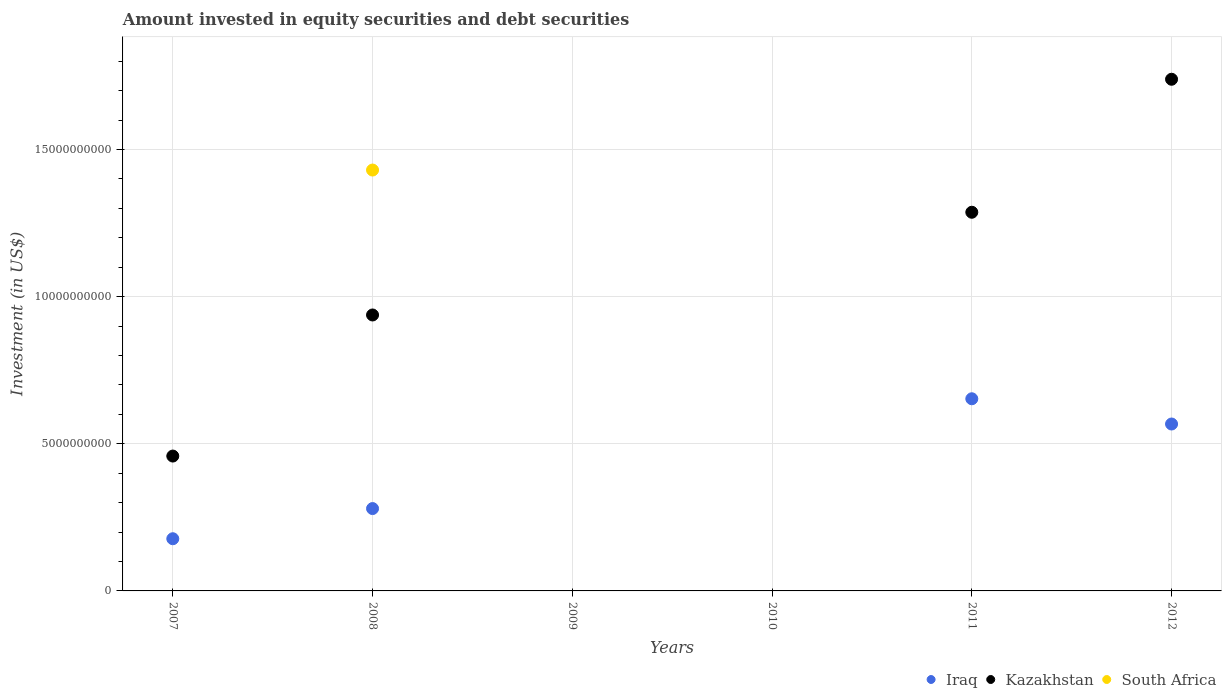Is the number of dotlines equal to the number of legend labels?
Offer a terse response. No. What is the amount invested in equity securities and debt securities in Kazakhstan in 2010?
Give a very brief answer. 0. Across all years, what is the maximum amount invested in equity securities and debt securities in Iraq?
Keep it short and to the point. 6.53e+09. What is the total amount invested in equity securities and debt securities in South Africa in the graph?
Your response must be concise. 1.43e+1. What is the difference between the amount invested in equity securities and debt securities in Kazakhstan in 2012 and the amount invested in equity securities and debt securities in Iraq in 2010?
Offer a very short reply. 1.74e+1. What is the average amount invested in equity securities and debt securities in South Africa per year?
Your answer should be very brief. 2.38e+09. In the year 2008, what is the difference between the amount invested in equity securities and debt securities in South Africa and amount invested in equity securities and debt securities in Kazakhstan?
Give a very brief answer. 4.93e+09. In how many years, is the amount invested in equity securities and debt securities in Iraq greater than 14000000000 US$?
Offer a very short reply. 0. What is the ratio of the amount invested in equity securities and debt securities in Kazakhstan in 2007 to that in 2008?
Provide a succinct answer. 0.49. Is the amount invested in equity securities and debt securities in Kazakhstan in 2008 less than that in 2012?
Make the answer very short. Yes. What is the difference between the highest and the second highest amount invested in equity securities and debt securities in Iraq?
Keep it short and to the point. 8.58e+08. What is the difference between the highest and the lowest amount invested in equity securities and debt securities in South Africa?
Offer a very short reply. 1.43e+1. In how many years, is the amount invested in equity securities and debt securities in Iraq greater than the average amount invested in equity securities and debt securities in Iraq taken over all years?
Offer a terse response. 3. Is the sum of the amount invested in equity securities and debt securities in Kazakhstan in 2007 and 2012 greater than the maximum amount invested in equity securities and debt securities in Iraq across all years?
Offer a very short reply. Yes. Is it the case that in every year, the sum of the amount invested in equity securities and debt securities in South Africa and amount invested in equity securities and debt securities in Iraq  is greater than the amount invested in equity securities and debt securities in Kazakhstan?
Your answer should be very brief. No. Does the amount invested in equity securities and debt securities in Kazakhstan monotonically increase over the years?
Your answer should be very brief. No. Is the amount invested in equity securities and debt securities in Iraq strictly less than the amount invested in equity securities and debt securities in Kazakhstan over the years?
Give a very brief answer. No. How many years are there in the graph?
Provide a succinct answer. 6. What is the difference between two consecutive major ticks on the Y-axis?
Make the answer very short. 5.00e+09. Are the values on the major ticks of Y-axis written in scientific E-notation?
Offer a very short reply. No. Does the graph contain any zero values?
Ensure brevity in your answer.  Yes. Where does the legend appear in the graph?
Your response must be concise. Bottom right. How many legend labels are there?
Ensure brevity in your answer.  3. How are the legend labels stacked?
Give a very brief answer. Horizontal. What is the title of the graph?
Offer a terse response. Amount invested in equity securities and debt securities. What is the label or title of the X-axis?
Make the answer very short. Years. What is the label or title of the Y-axis?
Keep it short and to the point. Investment (in US$). What is the Investment (in US$) in Iraq in 2007?
Your answer should be very brief. 1.77e+09. What is the Investment (in US$) in Kazakhstan in 2007?
Make the answer very short. 4.58e+09. What is the Investment (in US$) in Iraq in 2008?
Provide a succinct answer. 2.80e+09. What is the Investment (in US$) of Kazakhstan in 2008?
Make the answer very short. 9.38e+09. What is the Investment (in US$) of South Africa in 2008?
Make the answer very short. 1.43e+1. What is the Investment (in US$) of Kazakhstan in 2009?
Give a very brief answer. 0. What is the Investment (in US$) in South Africa in 2010?
Your answer should be compact. 0. What is the Investment (in US$) of Iraq in 2011?
Keep it short and to the point. 6.53e+09. What is the Investment (in US$) in Kazakhstan in 2011?
Ensure brevity in your answer.  1.29e+1. What is the Investment (in US$) of Iraq in 2012?
Offer a very short reply. 5.67e+09. What is the Investment (in US$) in Kazakhstan in 2012?
Offer a terse response. 1.74e+1. What is the Investment (in US$) in South Africa in 2012?
Give a very brief answer. 0. Across all years, what is the maximum Investment (in US$) of Iraq?
Give a very brief answer. 6.53e+09. Across all years, what is the maximum Investment (in US$) of Kazakhstan?
Give a very brief answer. 1.74e+1. Across all years, what is the maximum Investment (in US$) in South Africa?
Make the answer very short. 1.43e+1. Across all years, what is the minimum Investment (in US$) of Kazakhstan?
Offer a very short reply. 0. Across all years, what is the minimum Investment (in US$) in South Africa?
Offer a very short reply. 0. What is the total Investment (in US$) in Iraq in the graph?
Offer a terse response. 1.68e+1. What is the total Investment (in US$) of Kazakhstan in the graph?
Keep it short and to the point. 4.42e+1. What is the total Investment (in US$) in South Africa in the graph?
Offer a terse response. 1.43e+1. What is the difference between the Investment (in US$) in Iraq in 2007 and that in 2008?
Offer a very short reply. -1.03e+09. What is the difference between the Investment (in US$) in Kazakhstan in 2007 and that in 2008?
Your answer should be compact. -4.79e+09. What is the difference between the Investment (in US$) in Iraq in 2007 and that in 2011?
Ensure brevity in your answer.  -4.76e+09. What is the difference between the Investment (in US$) of Kazakhstan in 2007 and that in 2011?
Keep it short and to the point. -8.29e+09. What is the difference between the Investment (in US$) of Iraq in 2007 and that in 2012?
Your answer should be compact. -3.90e+09. What is the difference between the Investment (in US$) in Kazakhstan in 2007 and that in 2012?
Ensure brevity in your answer.  -1.28e+1. What is the difference between the Investment (in US$) in Iraq in 2008 and that in 2011?
Your answer should be compact. -3.73e+09. What is the difference between the Investment (in US$) in Kazakhstan in 2008 and that in 2011?
Give a very brief answer. -3.49e+09. What is the difference between the Investment (in US$) in Iraq in 2008 and that in 2012?
Provide a succinct answer. -2.87e+09. What is the difference between the Investment (in US$) of Kazakhstan in 2008 and that in 2012?
Offer a terse response. -8.01e+09. What is the difference between the Investment (in US$) of Iraq in 2011 and that in 2012?
Your response must be concise. 8.58e+08. What is the difference between the Investment (in US$) in Kazakhstan in 2011 and that in 2012?
Offer a terse response. -4.52e+09. What is the difference between the Investment (in US$) of Iraq in 2007 and the Investment (in US$) of Kazakhstan in 2008?
Keep it short and to the point. -7.60e+09. What is the difference between the Investment (in US$) in Iraq in 2007 and the Investment (in US$) in South Africa in 2008?
Offer a very short reply. -1.25e+1. What is the difference between the Investment (in US$) of Kazakhstan in 2007 and the Investment (in US$) of South Africa in 2008?
Provide a succinct answer. -9.72e+09. What is the difference between the Investment (in US$) of Iraq in 2007 and the Investment (in US$) of Kazakhstan in 2011?
Your response must be concise. -1.11e+1. What is the difference between the Investment (in US$) in Iraq in 2007 and the Investment (in US$) in Kazakhstan in 2012?
Your answer should be compact. -1.56e+1. What is the difference between the Investment (in US$) of Iraq in 2008 and the Investment (in US$) of Kazakhstan in 2011?
Make the answer very short. -1.01e+1. What is the difference between the Investment (in US$) in Iraq in 2008 and the Investment (in US$) in Kazakhstan in 2012?
Your response must be concise. -1.46e+1. What is the difference between the Investment (in US$) in Iraq in 2011 and the Investment (in US$) in Kazakhstan in 2012?
Provide a short and direct response. -1.09e+1. What is the average Investment (in US$) of Iraq per year?
Your response must be concise. 2.80e+09. What is the average Investment (in US$) of Kazakhstan per year?
Keep it short and to the point. 7.37e+09. What is the average Investment (in US$) of South Africa per year?
Provide a succinct answer. 2.38e+09. In the year 2007, what is the difference between the Investment (in US$) in Iraq and Investment (in US$) in Kazakhstan?
Give a very brief answer. -2.81e+09. In the year 2008, what is the difference between the Investment (in US$) of Iraq and Investment (in US$) of Kazakhstan?
Offer a very short reply. -6.58e+09. In the year 2008, what is the difference between the Investment (in US$) in Iraq and Investment (in US$) in South Africa?
Make the answer very short. -1.15e+1. In the year 2008, what is the difference between the Investment (in US$) of Kazakhstan and Investment (in US$) of South Africa?
Make the answer very short. -4.93e+09. In the year 2011, what is the difference between the Investment (in US$) of Iraq and Investment (in US$) of Kazakhstan?
Provide a short and direct response. -6.34e+09. In the year 2012, what is the difference between the Investment (in US$) in Iraq and Investment (in US$) in Kazakhstan?
Ensure brevity in your answer.  -1.17e+1. What is the ratio of the Investment (in US$) in Iraq in 2007 to that in 2008?
Offer a very short reply. 0.63. What is the ratio of the Investment (in US$) in Kazakhstan in 2007 to that in 2008?
Give a very brief answer. 0.49. What is the ratio of the Investment (in US$) of Iraq in 2007 to that in 2011?
Give a very brief answer. 0.27. What is the ratio of the Investment (in US$) of Kazakhstan in 2007 to that in 2011?
Your answer should be very brief. 0.36. What is the ratio of the Investment (in US$) in Iraq in 2007 to that in 2012?
Ensure brevity in your answer.  0.31. What is the ratio of the Investment (in US$) of Kazakhstan in 2007 to that in 2012?
Your response must be concise. 0.26. What is the ratio of the Investment (in US$) of Iraq in 2008 to that in 2011?
Offer a very short reply. 0.43. What is the ratio of the Investment (in US$) of Kazakhstan in 2008 to that in 2011?
Keep it short and to the point. 0.73. What is the ratio of the Investment (in US$) in Iraq in 2008 to that in 2012?
Provide a short and direct response. 0.49. What is the ratio of the Investment (in US$) of Kazakhstan in 2008 to that in 2012?
Provide a succinct answer. 0.54. What is the ratio of the Investment (in US$) in Iraq in 2011 to that in 2012?
Offer a terse response. 1.15. What is the ratio of the Investment (in US$) of Kazakhstan in 2011 to that in 2012?
Offer a very short reply. 0.74. What is the difference between the highest and the second highest Investment (in US$) in Iraq?
Ensure brevity in your answer.  8.58e+08. What is the difference between the highest and the second highest Investment (in US$) of Kazakhstan?
Offer a terse response. 4.52e+09. What is the difference between the highest and the lowest Investment (in US$) in Iraq?
Give a very brief answer. 6.53e+09. What is the difference between the highest and the lowest Investment (in US$) in Kazakhstan?
Give a very brief answer. 1.74e+1. What is the difference between the highest and the lowest Investment (in US$) in South Africa?
Give a very brief answer. 1.43e+1. 